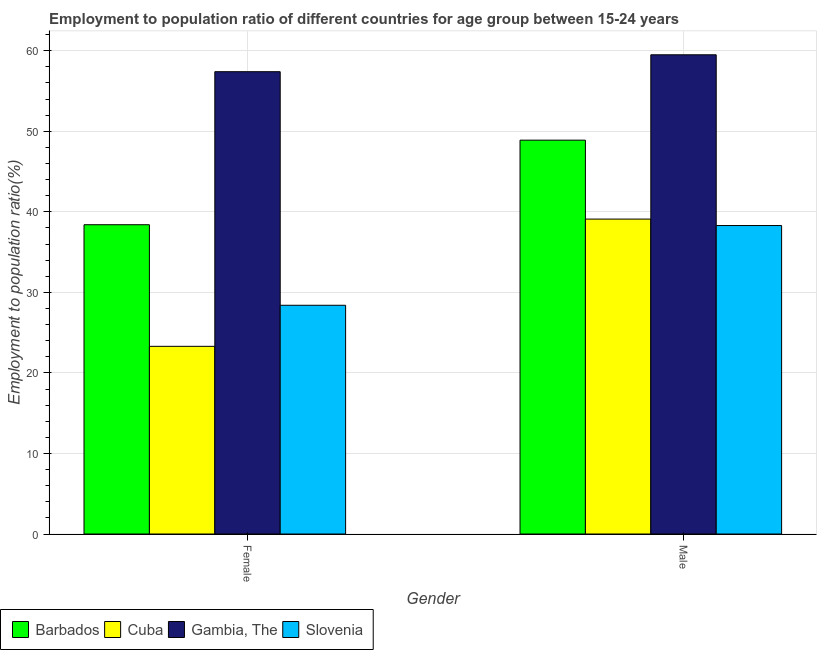How many groups of bars are there?
Keep it short and to the point. 2. Are the number of bars per tick equal to the number of legend labels?
Make the answer very short. Yes. Are the number of bars on each tick of the X-axis equal?
Offer a terse response. Yes. How many bars are there on the 2nd tick from the right?
Your answer should be compact. 4. What is the employment to population ratio(male) in Gambia, The?
Offer a terse response. 59.5. Across all countries, what is the maximum employment to population ratio(female)?
Keep it short and to the point. 57.4. Across all countries, what is the minimum employment to population ratio(male)?
Ensure brevity in your answer.  38.3. In which country was the employment to population ratio(female) maximum?
Make the answer very short. Gambia, The. In which country was the employment to population ratio(male) minimum?
Keep it short and to the point. Slovenia. What is the total employment to population ratio(male) in the graph?
Ensure brevity in your answer.  185.8. What is the difference between the employment to population ratio(female) in Barbados and that in Gambia, The?
Make the answer very short. -19. What is the difference between the employment to population ratio(male) in Slovenia and the employment to population ratio(female) in Gambia, The?
Your response must be concise. -19.1. What is the average employment to population ratio(female) per country?
Provide a succinct answer. 36.88. What is the difference between the employment to population ratio(male) and employment to population ratio(female) in Cuba?
Give a very brief answer. 15.8. What is the ratio of the employment to population ratio(female) in Barbados to that in Cuba?
Provide a succinct answer. 1.65. What does the 1st bar from the left in Female represents?
Your answer should be compact. Barbados. What does the 2nd bar from the right in Male represents?
Your answer should be compact. Gambia, The. How are the legend labels stacked?
Make the answer very short. Horizontal. What is the title of the graph?
Offer a terse response. Employment to population ratio of different countries for age group between 15-24 years. What is the label or title of the Y-axis?
Provide a succinct answer. Employment to population ratio(%). What is the Employment to population ratio(%) of Barbados in Female?
Give a very brief answer. 38.4. What is the Employment to population ratio(%) in Cuba in Female?
Provide a succinct answer. 23.3. What is the Employment to population ratio(%) of Gambia, The in Female?
Your answer should be very brief. 57.4. What is the Employment to population ratio(%) in Slovenia in Female?
Your response must be concise. 28.4. What is the Employment to population ratio(%) in Barbados in Male?
Ensure brevity in your answer.  48.9. What is the Employment to population ratio(%) of Cuba in Male?
Ensure brevity in your answer.  39.1. What is the Employment to population ratio(%) of Gambia, The in Male?
Provide a succinct answer. 59.5. What is the Employment to population ratio(%) in Slovenia in Male?
Your answer should be very brief. 38.3. Across all Gender, what is the maximum Employment to population ratio(%) of Barbados?
Ensure brevity in your answer.  48.9. Across all Gender, what is the maximum Employment to population ratio(%) in Cuba?
Your response must be concise. 39.1. Across all Gender, what is the maximum Employment to population ratio(%) in Gambia, The?
Give a very brief answer. 59.5. Across all Gender, what is the maximum Employment to population ratio(%) in Slovenia?
Ensure brevity in your answer.  38.3. Across all Gender, what is the minimum Employment to population ratio(%) of Barbados?
Your response must be concise. 38.4. Across all Gender, what is the minimum Employment to population ratio(%) in Cuba?
Your answer should be very brief. 23.3. Across all Gender, what is the minimum Employment to population ratio(%) of Gambia, The?
Your response must be concise. 57.4. Across all Gender, what is the minimum Employment to population ratio(%) of Slovenia?
Offer a very short reply. 28.4. What is the total Employment to population ratio(%) in Barbados in the graph?
Make the answer very short. 87.3. What is the total Employment to population ratio(%) in Cuba in the graph?
Your answer should be compact. 62.4. What is the total Employment to population ratio(%) in Gambia, The in the graph?
Make the answer very short. 116.9. What is the total Employment to population ratio(%) in Slovenia in the graph?
Your answer should be very brief. 66.7. What is the difference between the Employment to population ratio(%) in Cuba in Female and that in Male?
Your answer should be very brief. -15.8. What is the difference between the Employment to population ratio(%) of Gambia, The in Female and that in Male?
Your answer should be compact. -2.1. What is the difference between the Employment to population ratio(%) of Barbados in Female and the Employment to population ratio(%) of Cuba in Male?
Your response must be concise. -0.7. What is the difference between the Employment to population ratio(%) of Barbados in Female and the Employment to population ratio(%) of Gambia, The in Male?
Offer a very short reply. -21.1. What is the difference between the Employment to population ratio(%) in Barbados in Female and the Employment to population ratio(%) in Slovenia in Male?
Your answer should be compact. 0.1. What is the difference between the Employment to population ratio(%) of Cuba in Female and the Employment to population ratio(%) of Gambia, The in Male?
Your answer should be very brief. -36.2. What is the difference between the Employment to population ratio(%) in Cuba in Female and the Employment to population ratio(%) in Slovenia in Male?
Your response must be concise. -15. What is the difference between the Employment to population ratio(%) of Gambia, The in Female and the Employment to population ratio(%) of Slovenia in Male?
Your response must be concise. 19.1. What is the average Employment to population ratio(%) in Barbados per Gender?
Keep it short and to the point. 43.65. What is the average Employment to population ratio(%) in Cuba per Gender?
Make the answer very short. 31.2. What is the average Employment to population ratio(%) in Gambia, The per Gender?
Provide a short and direct response. 58.45. What is the average Employment to population ratio(%) of Slovenia per Gender?
Provide a succinct answer. 33.35. What is the difference between the Employment to population ratio(%) of Barbados and Employment to population ratio(%) of Gambia, The in Female?
Your answer should be compact. -19. What is the difference between the Employment to population ratio(%) of Cuba and Employment to population ratio(%) of Gambia, The in Female?
Offer a terse response. -34.1. What is the difference between the Employment to population ratio(%) of Cuba and Employment to population ratio(%) of Slovenia in Female?
Offer a terse response. -5.1. What is the difference between the Employment to population ratio(%) in Barbados and Employment to population ratio(%) in Cuba in Male?
Keep it short and to the point. 9.8. What is the difference between the Employment to population ratio(%) in Barbados and Employment to population ratio(%) in Gambia, The in Male?
Make the answer very short. -10.6. What is the difference between the Employment to population ratio(%) of Cuba and Employment to population ratio(%) of Gambia, The in Male?
Give a very brief answer. -20.4. What is the difference between the Employment to population ratio(%) of Cuba and Employment to population ratio(%) of Slovenia in Male?
Your answer should be very brief. 0.8. What is the difference between the Employment to population ratio(%) in Gambia, The and Employment to population ratio(%) in Slovenia in Male?
Your response must be concise. 21.2. What is the ratio of the Employment to population ratio(%) of Barbados in Female to that in Male?
Your response must be concise. 0.79. What is the ratio of the Employment to population ratio(%) of Cuba in Female to that in Male?
Ensure brevity in your answer.  0.6. What is the ratio of the Employment to population ratio(%) of Gambia, The in Female to that in Male?
Your answer should be compact. 0.96. What is the ratio of the Employment to population ratio(%) of Slovenia in Female to that in Male?
Your answer should be very brief. 0.74. What is the difference between the highest and the second highest Employment to population ratio(%) of Barbados?
Provide a short and direct response. 10.5. What is the difference between the highest and the second highest Employment to population ratio(%) of Gambia, The?
Provide a succinct answer. 2.1. What is the difference between the highest and the second highest Employment to population ratio(%) of Slovenia?
Keep it short and to the point. 9.9. What is the difference between the highest and the lowest Employment to population ratio(%) in Barbados?
Your response must be concise. 10.5. 